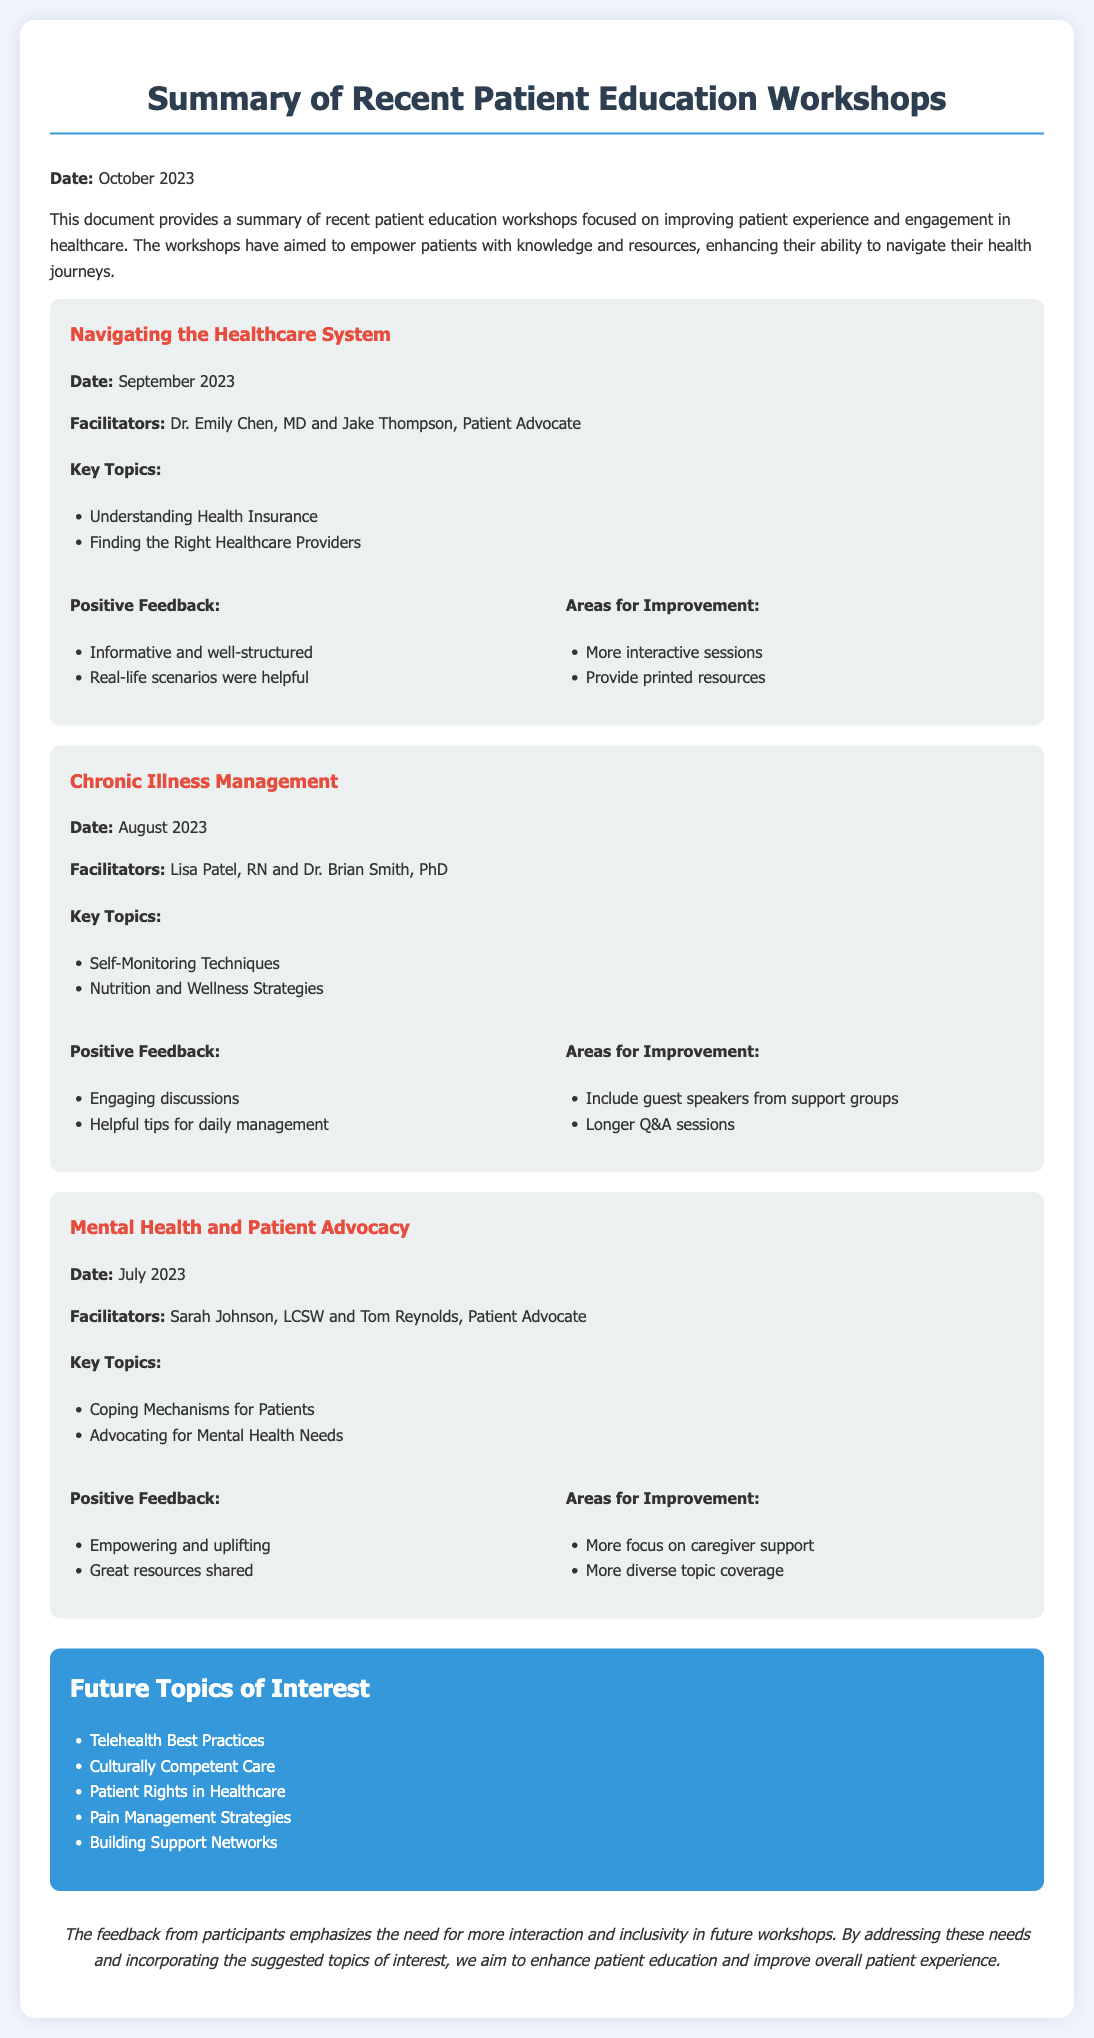What is the date of the latest workshop? The latest workshop is titled "Navigating the Healthcare System," which occurred in September 2023.
Answer: September 2023 Who facilitated the "Chronic Illness Management" workshop? The workshop "Chronic Illness Management" was facilitated by Lisa Patel, RN and Dr. Brian Smith, PhD.
Answer: Lisa Patel, RN and Dr. Brian Smith, PhD What is one of the key topics covered in the "Mental Health and Patient Advocacy" workshop? A key topic covered in the workshop "Mental Health and Patient Advocacy" is "Coping Mechanisms for Patients."
Answer: Coping Mechanisms for Patients What were participants encouraged to focus on for the future workshop topics? Participants expressed interest in various future topics, including "Telehealth Best Practices," which has been listed.
Answer: Telehealth Best Practices What type of feedback was received for the "Navigating the Healthcare System" workshop? The feedback included positive aspects such as being "Informative and well-structured," as well as suggestions for improvement like "More interactive sessions."
Answer: Informative and well-structured How many workshops are mentioned in the document? There are three workshops summarized in the document, outlining different educational topics.
Answer: Three What area of improvement was suggested for the "Chronic Illness Management" workshop? One area for improvement suggested for this workshop was to "Include guest speakers from support groups."
Answer: Include guest speakers from support groups What color is used for the future topics section? The color used for the future topics section is blue, specifically #3498db.
Answer: Blue What is the main theme of the workshops? The main theme of the workshops is focused on "improving patient experience and engagement in healthcare."
Answer: Improving patient experience and engagement in healthcare 